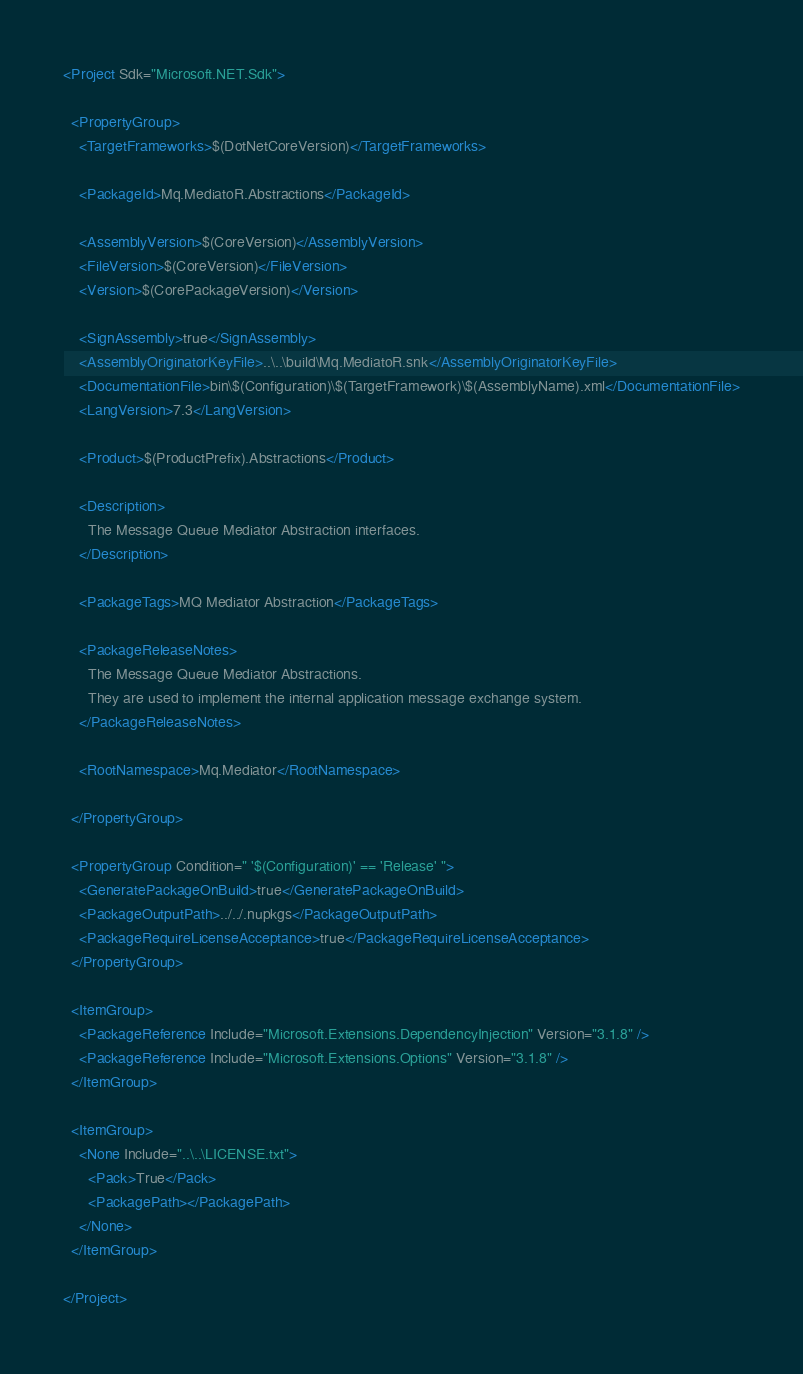<code> <loc_0><loc_0><loc_500><loc_500><_XML_><Project Sdk="Microsoft.NET.Sdk">

  <PropertyGroup>
    <TargetFrameworks>$(DotNetCoreVersion)</TargetFrameworks>
    
    <PackageId>Mq.MediatoR.Abstractions</PackageId>

    <AssemblyVersion>$(CoreVersion)</AssemblyVersion>
    <FileVersion>$(CoreVersion)</FileVersion>
    <Version>$(CorePackageVersion)</Version>

    <SignAssembly>true</SignAssembly>
    <AssemblyOriginatorKeyFile>..\..\build\Mq.MediatoR.snk</AssemblyOriginatorKeyFile>
    <DocumentationFile>bin\$(Configuration)\$(TargetFramework)\$(AssemblyName).xml</DocumentationFile>
    <LangVersion>7.3</LangVersion>
    
    <Product>$(ProductPrefix).Abstractions</Product>

    <Description>
      The Message Queue Mediator Abstraction interfaces.
    </Description>
    
    <PackageTags>MQ Mediator Abstraction</PackageTags>
    
    <PackageReleaseNotes>
      The Message Queue Mediator Abstractions.
      They are used to implement the internal application message exchange system.
    </PackageReleaseNotes>
    
    <RootNamespace>Mq.Mediator</RootNamespace>
    
  </PropertyGroup>

  <PropertyGroup Condition=" '$(Configuration)' == 'Release' ">
    <GeneratePackageOnBuild>true</GeneratePackageOnBuild>
    <PackageOutputPath>../../.nupkgs</PackageOutputPath>
    <PackageRequireLicenseAcceptance>true</PackageRequireLicenseAcceptance>
  </PropertyGroup>
  
  <ItemGroup>
    <PackageReference Include="Microsoft.Extensions.DependencyInjection" Version="3.1.8" />
    <PackageReference Include="Microsoft.Extensions.Options" Version="3.1.8" />
  </ItemGroup>
  
  <ItemGroup>
    <None Include="..\..\LICENSE.txt">
      <Pack>True</Pack>
      <PackagePath></PackagePath>
    </None>
  </ItemGroup>
  
</Project>
</code> 